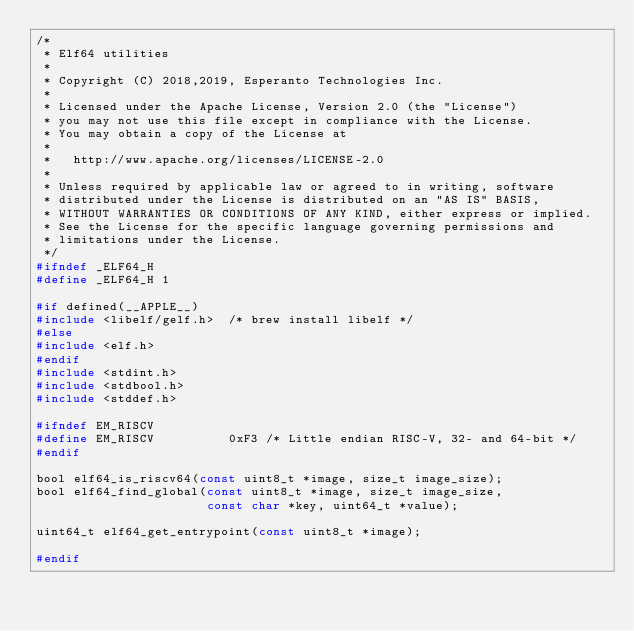<code> <loc_0><loc_0><loc_500><loc_500><_C_>/*
 * Elf64 utilities
 *
 * Copyright (C) 2018,2019, Esperanto Technologies Inc.
 *
 * Licensed under the Apache License, Version 2.0 (the "License")
 * you may not use this file except in compliance with the License.
 * You may obtain a copy of the License at
 *
 *   http://www.apache.org/licenses/LICENSE-2.0
 *
 * Unless required by applicable law or agreed to in writing, software
 * distributed under the License is distributed on an "AS IS" BASIS,
 * WITHOUT WARRANTIES OR CONDITIONS OF ANY KIND, either express or implied.
 * See the License for the specific language governing permissions and
 * limitations under the License.
 */
#ifndef _ELF64_H
#define _ELF64_H 1

#if defined(__APPLE__)
#include <libelf/gelf.h>	/* brew install libelf */
#else
#include <elf.h>
#endif
#include <stdint.h>
#include <stdbool.h>
#include <stddef.h>

#ifndef EM_RISCV
#define EM_RISCV          0xF3 /* Little endian RISC-V, 32- and 64-bit */
#endif

bool elf64_is_riscv64(const uint8_t *image, size_t image_size);
bool elf64_find_global(const uint8_t *image, size_t image_size,
                       const char *key, uint64_t *value);

uint64_t elf64_get_entrypoint(const uint8_t *image);

#endif
</code> 